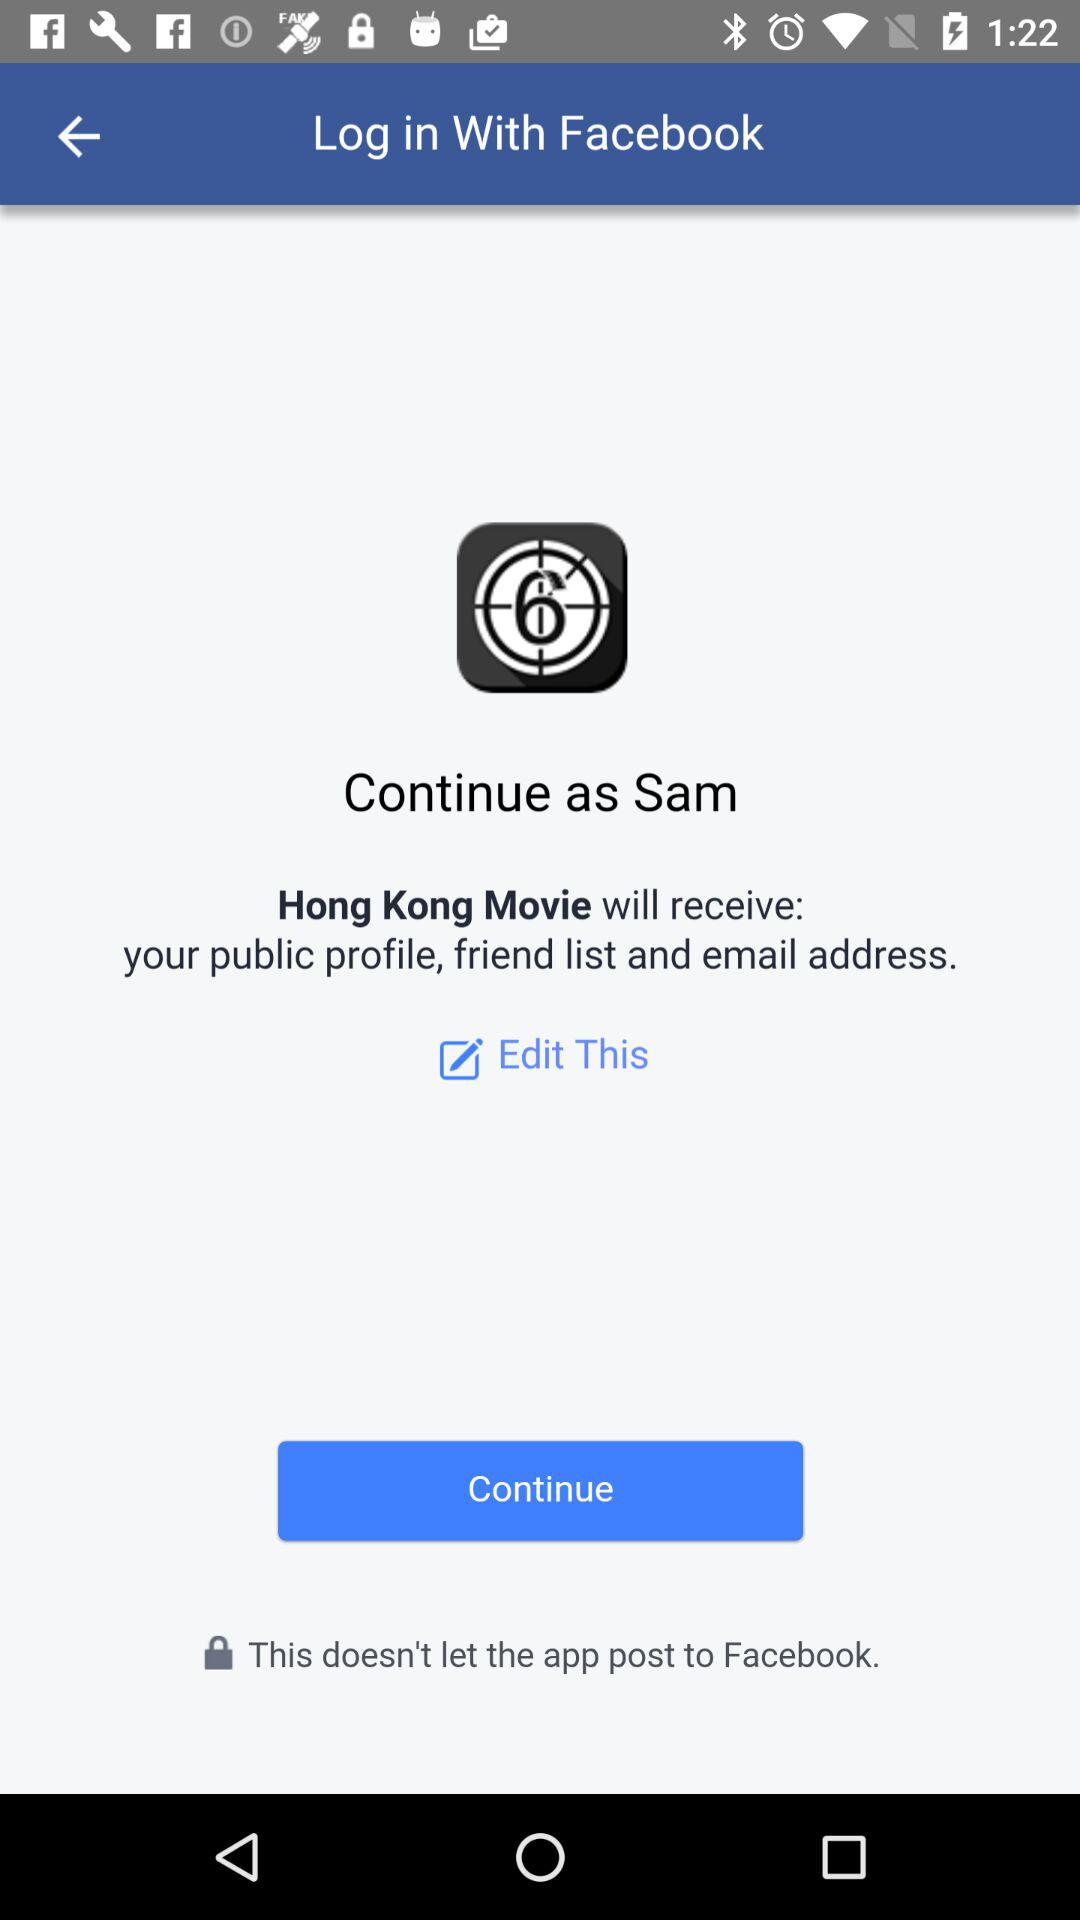What is the login name? The login name is Sam. 